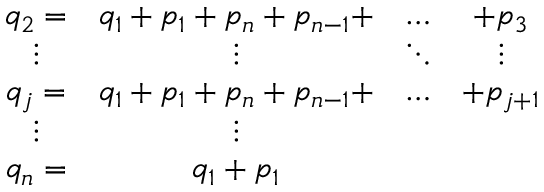<formula> <loc_0><loc_0><loc_500><loc_500>\begin{array} { c c c c } { { q _ { 2 } = } } & { { q _ { 1 } + p _ { 1 } + p _ { n } + p _ { n - 1 } + } } & { \dots } & { { + p _ { 3 } } } \\ { \vdots } & { \vdots } & { \ddots } & { \vdots } \\ { { q _ { j } = } } & { { q _ { 1 } + p _ { 1 } + p _ { n } + p _ { n - 1 } + } } & { \dots } & { { + p _ { j + 1 } } } \\ { \vdots } & { \vdots } \\ { { q _ { n } = } } & { { q _ { 1 } + p _ { 1 } } } \end{array}</formula> 